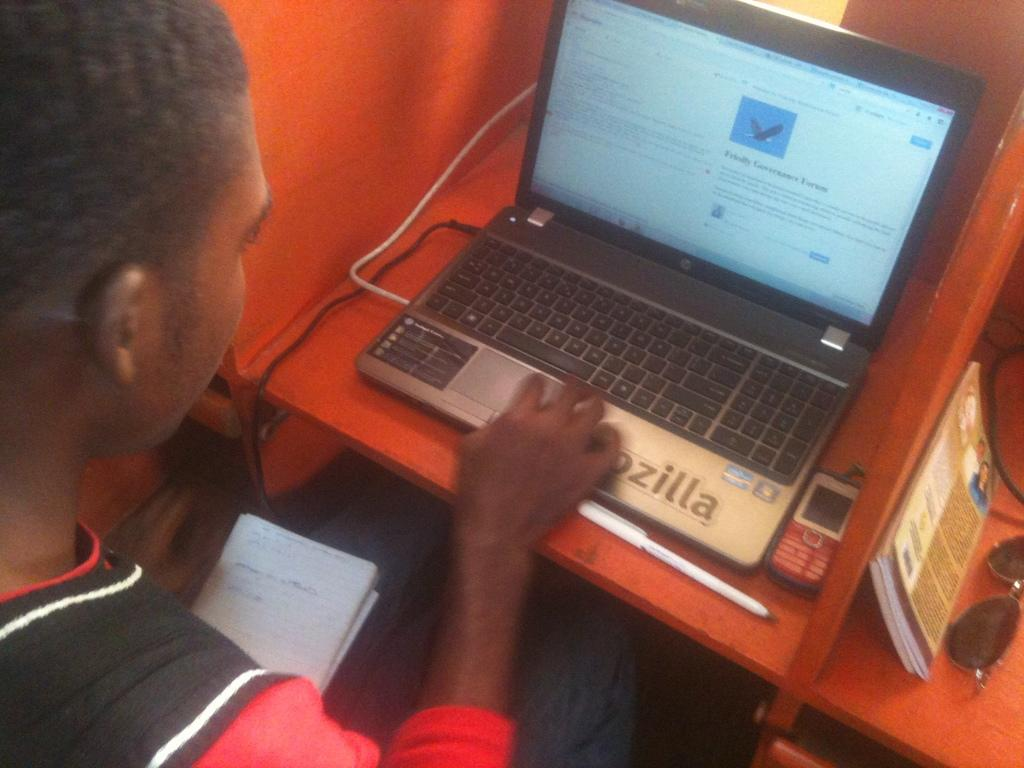Provide a one-sentence caption for the provided image. A man works on his laptop computer with a forum on the screen. 